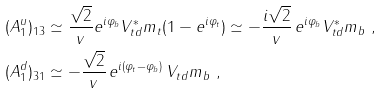<formula> <loc_0><loc_0><loc_500><loc_500>( A _ { 1 } ^ { u } ) _ { 1 3 } & \simeq \frac { \sqrt { 2 } } { v } e ^ { i \varphi _ { b } } V _ { t d } ^ { * } m _ { t } ( 1 - e ^ { i \varphi _ { t } } ) \simeq - \frac { i \sqrt { 2 } } { v } \, e ^ { i \varphi _ { b } } V _ { t d } ^ { * } m _ { b } \ , \\ ( A _ { 1 } ^ { d } ) _ { 3 1 } & \simeq - \frac { \sqrt { 2 } } { v } \, e ^ { i ( \varphi _ { t } - \varphi _ { b } ) } \, V _ { t d } m _ { b } \ ,</formula> 